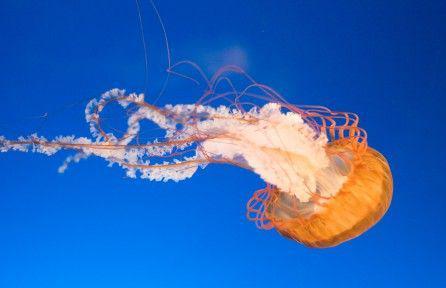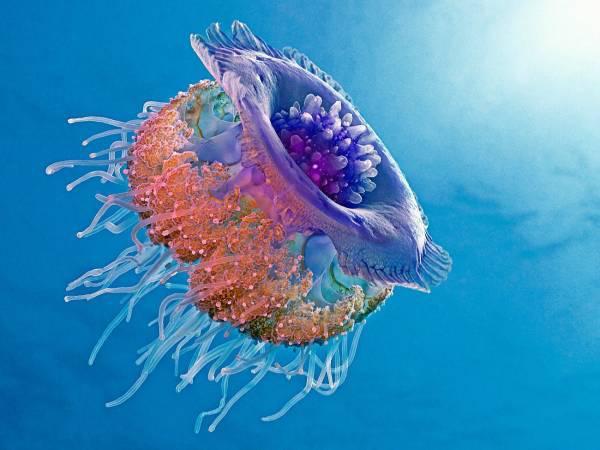The first image is the image on the left, the second image is the image on the right. For the images shown, is this caption "Each image contains exactly one jellyfish, and one image shows a jellyfish with its 'cap' turned rightward and its long tentacles trailing horizontally to the left." true? Answer yes or no. Yes. 